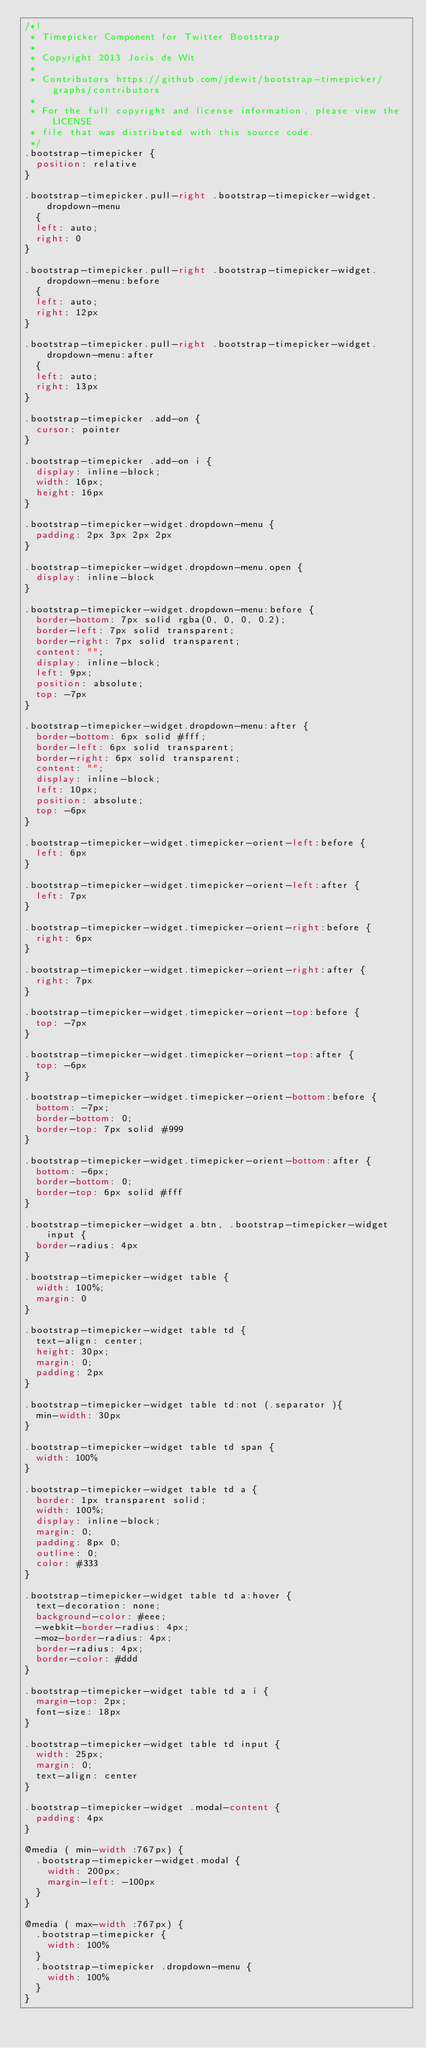Convert code to text. <code><loc_0><loc_0><loc_500><loc_500><_CSS_>/*!
 * Timepicker Component for Twitter Bootstrap
 *
 * Copyright 2013 Joris de Wit
 *
 * Contributors https://github.com/jdewit/bootstrap-timepicker/graphs/contributors
 *
 * For the full copyright and license information, please view the LICENSE
 * file that was distributed with this source code.
 */
.bootstrap-timepicker {
	position: relative
}

.bootstrap-timepicker.pull-right .bootstrap-timepicker-widget.dropdown-menu
	{
	left: auto;
	right: 0
}

.bootstrap-timepicker.pull-right .bootstrap-timepicker-widget.dropdown-menu:before
	{
	left: auto;
	right: 12px
}

.bootstrap-timepicker.pull-right .bootstrap-timepicker-widget.dropdown-menu:after
	{
	left: auto;
	right: 13px
}

.bootstrap-timepicker .add-on {
	cursor: pointer
}

.bootstrap-timepicker .add-on i {
	display: inline-block;
	width: 16px;
	height: 16px
}

.bootstrap-timepicker-widget.dropdown-menu {
	padding: 2px 3px 2px 2px
}

.bootstrap-timepicker-widget.dropdown-menu.open {
	display: inline-block
}

.bootstrap-timepicker-widget.dropdown-menu:before {
	border-bottom: 7px solid rgba(0, 0, 0, 0.2);
	border-left: 7px solid transparent;
	border-right: 7px solid transparent;
	content: "";
	display: inline-block;
	left: 9px;
	position: absolute;
	top: -7px
}

.bootstrap-timepicker-widget.dropdown-menu:after {
	border-bottom: 6px solid #fff;
	border-left: 6px solid transparent;
	border-right: 6px solid transparent;
	content: "";
	display: inline-block;
	left: 10px;
	position: absolute;
	top: -6px
}

.bootstrap-timepicker-widget.timepicker-orient-left:before {
	left: 6px
}

.bootstrap-timepicker-widget.timepicker-orient-left:after {
	left: 7px
}

.bootstrap-timepicker-widget.timepicker-orient-right:before {
	right: 6px
}

.bootstrap-timepicker-widget.timepicker-orient-right:after {
	right: 7px
}

.bootstrap-timepicker-widget.timepicker-orient-top:before {
	top: -7px
}

.bootstrap-timepicker-widget.timepicker-orient-top:after {
	top: -6px
}

.bootstrap-timepicker-widget.timepicker-orient-bottom:before {
	bottom: -7px;
	border-bottom: 0;
	border-top: 7px solid #999
}

.bootstrap-timepicker-widget.timepicker-orient-bottom:after {
	bottom: -6px;
	border-bottom: 0;
	border-top: 6px solid #fff
}

.bootstrap-timepicker-widget a.btn, .bootstrap-timepicker-widget input {
	border-radius: 4px
}

.bootstrap-timepicker-widget table {
	width: 100%;
	margin: 0
}

.bootstrap-timepicker-widget table td {
	text-align: center;
	height: 30px;
	margin: 0;
	padding: 2px
}

.bootstrap-timepicker-widget table td:not (.separator ){
	min-width: 30px
}

.bootstrap-timepicker-widget table td span {
	width: 100%
}

.bootstrap-timepicker-widget table td a {
	border: 1px transparent solid;
	width: 100%;
	display: inline-block;
	margin: 0;
	padding: 8px 0;
	outline: 0;
	color: #333
}

.bootstrap-timepicker-widget table td a:hover {
	text-decoration: none;
	background-color: #eee;
	-webkit-border-radius: 4px;
	-moz-border-radius: 4px;
	border-radius: 4px;
	border-color: #ddd
}

.bootstrap-timepicker-widget table td a i {
	margin-top: 2px;
	font-size: 18px
}

.bootstrap-timepicker-widget table td input {
	width: 25px;
	margin: 0;
	text-align: center
}

.bootstrap-timepicker-widget .modal-content {
	padding: 4px
}

@media ( min-width :767px) {
	.bootstrap-timepicker-widget.modal {
		width: 200px;
		margin-left: -100px
	}
}

@media ( max-width :767px) {
	.bootstrap-timepicker {
		width: 100%
	}
	.bootstrap-timepicker .dropdown-menu {
		width: 100%
	}
}</code> 